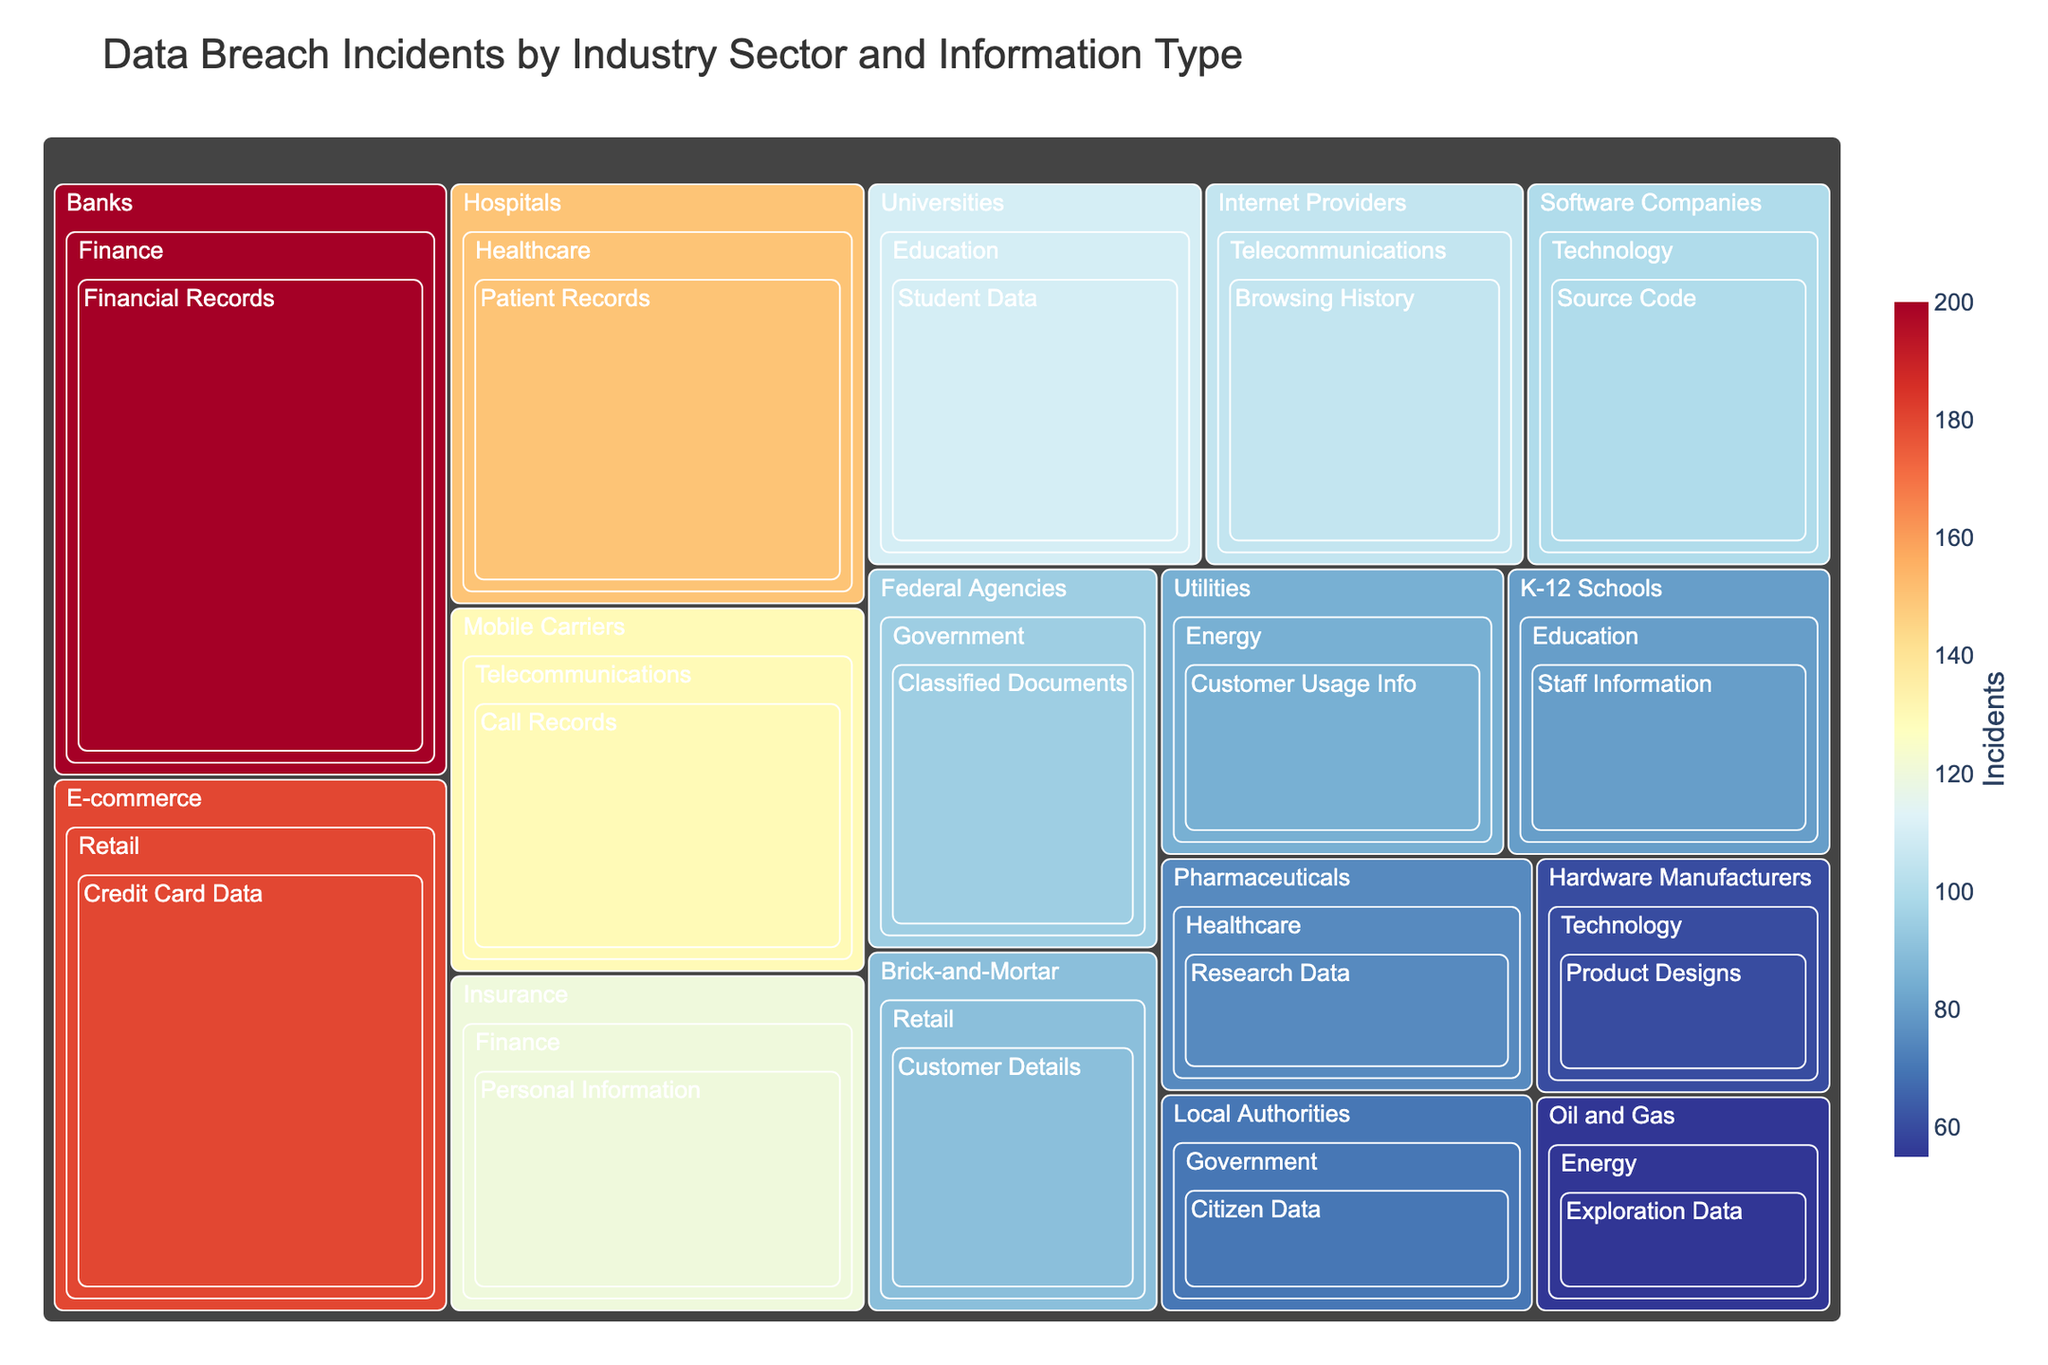Which industry sector has the highest number of total data breach incidents? By observing the areas within the treemap, Finance is the sector with the largest combined area for its industries, indicating the highest total number of incidents.
Answer: Finance What type of information within the Finance sector has more incidents: Financial Records or Personal Information? The treemap shows distinct tiles for both types. The tile for Financial Records within Finance is larger than the tile for Personal Information.
Answer: Financial Records How many incidents are there in the Technology sector? To find the total number of incidents in Technology, add incidents in Software Companies and Hardware Manufacturers: 100 + 60 = 160.
Answer: 160 Which type of information in the Healthcare sector has the fewer incidents: Patient Records or Research Data? Compare the sizes of the tiles within Healthcare. The tile for Research Data is smaller than for Patient Records.
Answer: Research Data What is the sum of incidents in the Telecommunications sector for both Mobile Carriers and Internet Providers? Add the incidents for Mobile Carriers and Internet Providers in the Telecommunications sector: 130 + 105 = 235.
Answer: 235 Which sector has more incidents: Education or Government? Compare the size of the areas associated with Education and Government sectors. Education has more combined area than Government, indicating more incidents.
Answer: Education Compare the number of incidents in Energy's Oil and Gas to Retail's Brick-and-Mortar. Which has more? By observing the treemap, the tile for Retail's Brick-and-Mortar has more incidents than Energy's Oil and Gas.
Answer: Retail's Brick-and-Mortar What type of information compromised in the Government sector has more incidents? The treemap shows tiles for Classified Documents and Citizen Data within the Government sector. The tile for Classified Documents is larger.
Answer: Classified Documents What's the total number of data breach incidents across all sectors? Sum all incident counts from each industry in the provided data set: 150 + 75 + 200 + 120 + 180 + 90 + 100 + 60 + 110 + 80 + 95 + 70 + 55 + 85 + 130 + 105 = 1705.
Answer: 1705 Which industry within the Retail sector has fewer data breach incidents? Compare the size of the tiles for E-commerce and Brick-and-Mortar within Retail. The tile for Brick-and-Mortar is smaller.
Answer: Brick-and-Mortar 